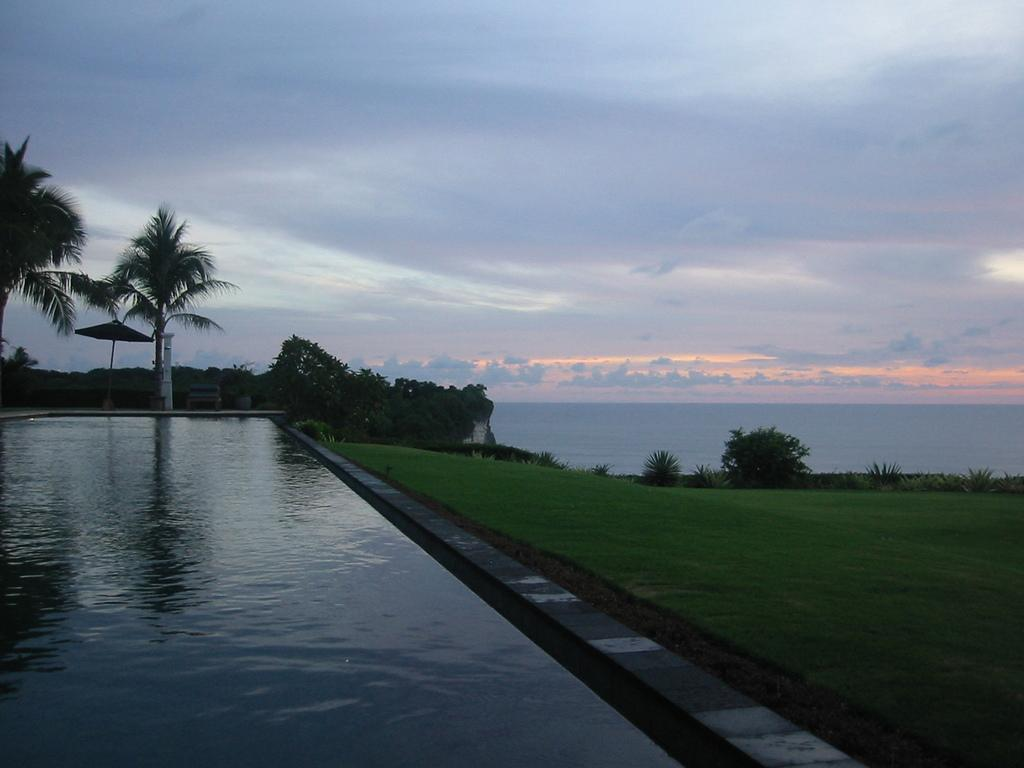What is one of the natural elements present in the image? There is water in the picture. What type of terrain can be seen in the image? There is grassland in the picture. Are there any plants visible in the image? Yes, there are trees in the picture. How would you describe the sky in the background of the image? The sky is cloudy in the background. What color is the crayon used to draw the trees in the image? There is no crayon present in the image, as the trees are real and not drawn. How many bricks are visible in the grassland area of the image? There are no bricks visible in the grassland area of the image. 